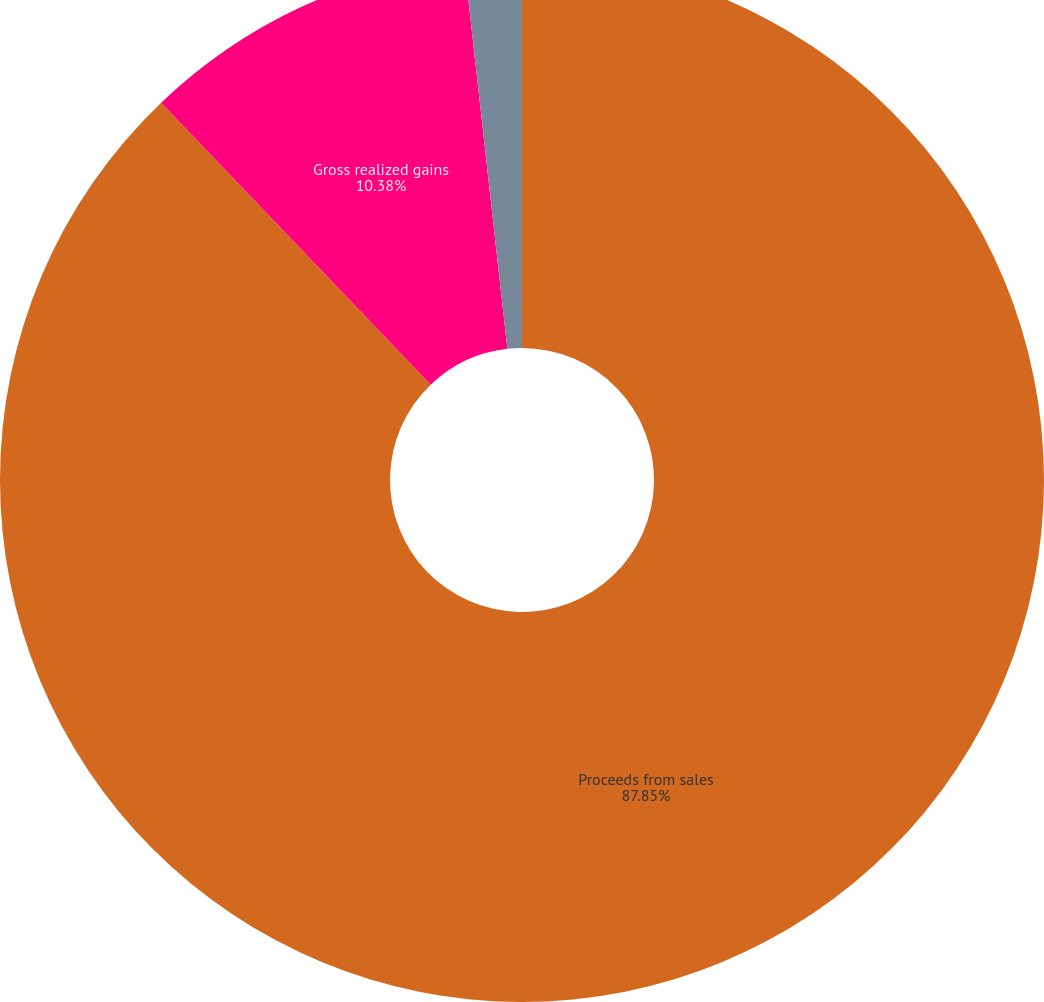<chart> <loc_0><loc_0><loc_500><loc_500><pie_chart><fcel>Proceeds from sales<fcel>Gross realized gains<fcel>Gross realized losses<nl><fcel>87.86%<fcel>10.38%<fcel>1.77%<nl></chart> 